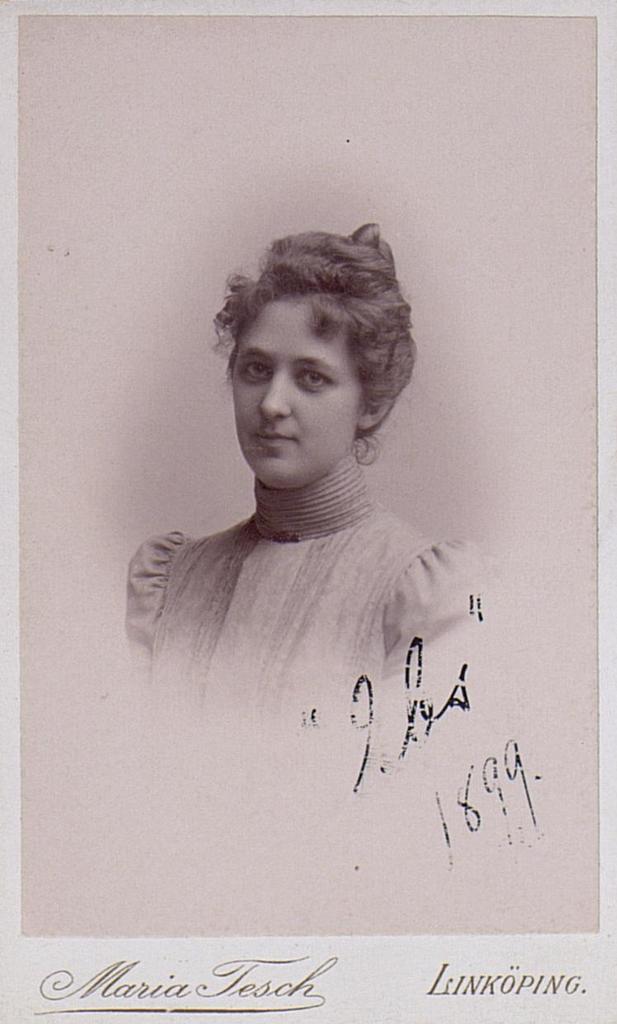Can you describe this image briefly? In this picture I can see a photo of a woman and there are words, numbers on the photo. 